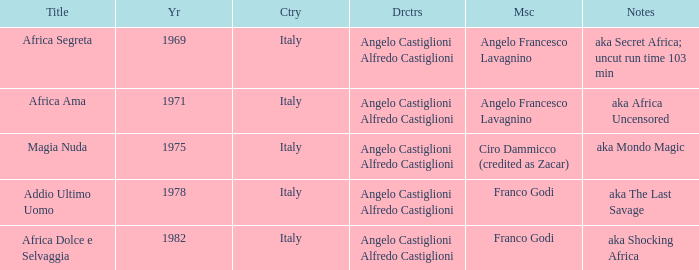How many years have a Title of Magia Nuda? 1.0. 